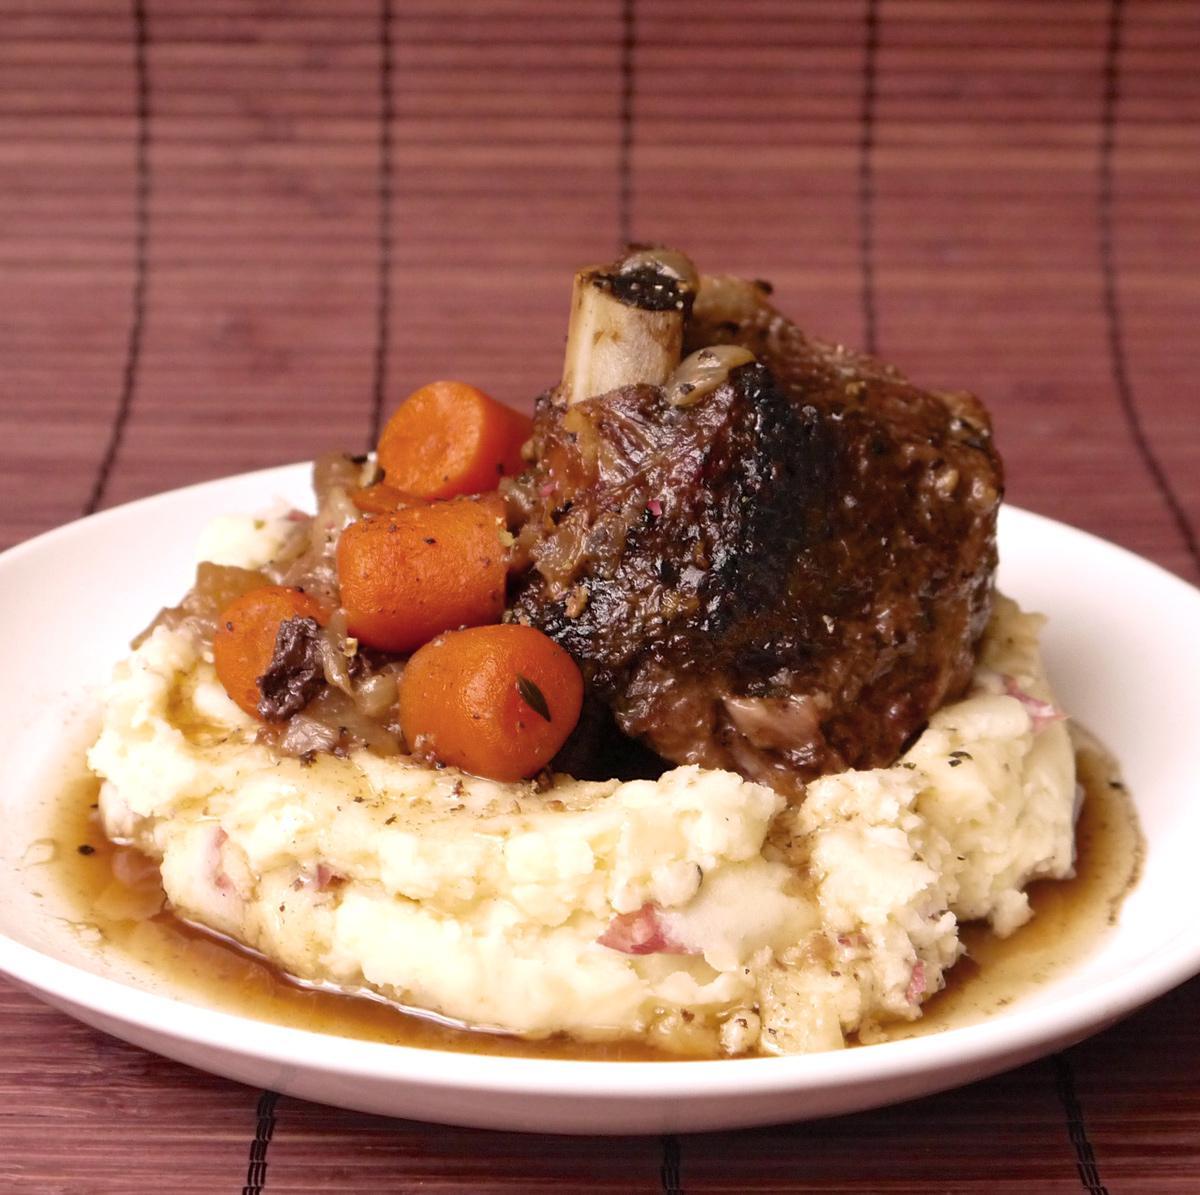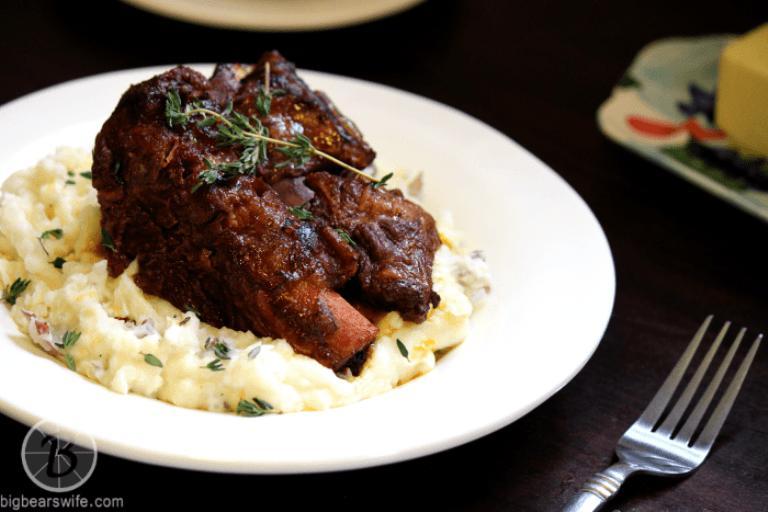The first image is the image on the left, the second image is the image on the right. Given the left and right images, does the statement "There are absolutely NO forks present." hold true? Answer yes or no. No. The first image is the image on the left, the second image is the image on the right. Evaluate the accuracy of this statement regarding the images: "there is a visible orange vegetable in the image on the left side.". Is it true? Answer yes or no. Yes. 